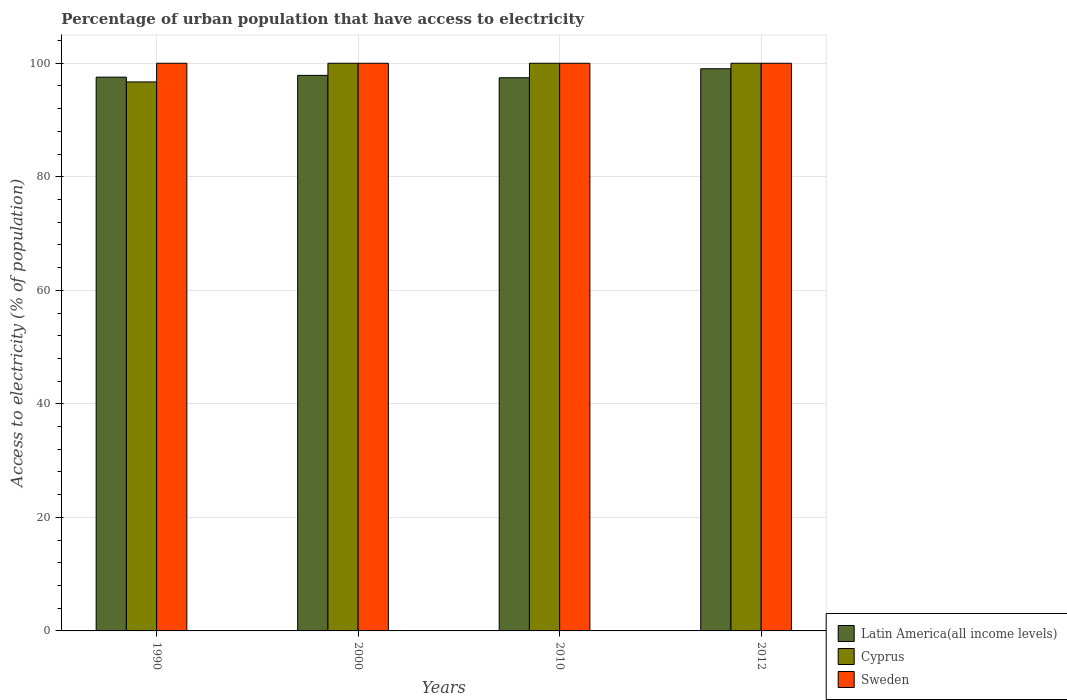How many groups of bars are there?
Your answer should be compact. 4. How many bars are there on the 1st tick from the left?
Your response must be concise. 3. What is the percentage of urban population that have access to electricity in Sweden in 2000?
Offer a terse response. 100. Across all years, what is the maximum percentage of urban population that have access to electricity in Latin America(all income levels)?
Give a very brief answer. 99.03. Across all years, what is the minimum percentage of urban population that have access to electricity in Latin America(all income levels)?
Your response must be concise. 97.45. In which year was the percentage of urban population that have access to electricity in Latin America(all income levels) maximum?
Your answer should be compact. 2012. In which year was the percentage of urban population that have access to electricity in Latin America(all income levels) minimum?
Your response must be concise. 2010. What is the total percentage of urban population that have access to electricity in Latin America(all income levels) in the graph?
Keep it short and to the point. 391.89. What is the difference between the percentage of urban population that have access to electricity in Cyprus in 1990 and that in 2010?
Your response must be concise. -3.29. What is the difference between the percentage of urban population that have access to electricity in Latin America(all income levels) in 2000 and the percentage of urban population that have access to electricity in Sweden in 2010?
Provide a short and direct response. -2.14. What is the average percentage of urban population that have access to electricity in Sweden per year?
Ensure brevity in your answer.  100. In the year 2012, what is the difference between the percentage of urban population that have access to electricity in Latin America(all income levels) and percentage of urban population that have access to electricity in Sweden?
Your answer should be very brief. -0.97. In how many years, is the percentage of urban population that have access to electricity in Sweden greater than 40 %?
Provide a short and direct response. 4. What is the ratio of the percentage of urban population that have access to electricity in Latin America(all income levels) in 1990 to that in 2012?
Your answer should be very brief. 0.99. Is the percentage of urban population that have access to electricity in Latin America(all income levels) in 2000 less than that in 2012?
Provide a succinct answer. Yes. What is the difference between the highest and the second highest percentage of urban population that have access to electricity in Cyprus?
Provide a succinct answer. 0. What is the difference between the highest and the lowest percentage of urban population that have access to electricity in Latin America(all income levels)?
Ensure brevity in your answer.  1.59. In how many years, is the percentage of urban population that have access to electricity in Cyprus greater than the average percentage of urban population that have access to electricity in Cyprus taken over all years?
Make the answer very short. 3. Is the sum of the percentage of urban population that have access to electricity in Cyprus in 1990 and 2000 greater than the maximum percentage of urban population that have access to electricity in Latin America(all income levels) across all years?
Offer a terse response. Yes. What does the 2nd bar from the left in 2012 represents?
Your response must be concise. Cyprus. How many bars are there?
Make the answer very short. 12. Are all the bars in the graph horizontal?
Ensure brevity in your answer.  No. How many years are there in the graph?
Offer a very short reply. 4. What is the difference between two consecutive major ticks on the Y-axis?
Give a very brief answer. 20. Are the values on the major ticks of Y-axis written in scientific E-notation?
Give a very brief answer. No. Where does the legend appear in the graph?
Your response must be concise. Bottom right. How are the legend labels stacked?
Ensure brevity in your answer.  Vertical. What is the title of the graph?
Your response must be concise. Percentage of urban population that have access to electricity. Does "Venezuela" appear as one of the legend labels in the graph?
Your answer should be compact. No. What is the label or title of the X-axis?
Give a very brief answer. Years. What is the label or title of the Y-axis?
Provide a short and direct response. Access to electricity (% of population). What is the Access to electricity (% of population) in Latin America(all income levels) in 1990?
Provide a short and direct response. 97.55. What is the Access to electricity (% of population) of Cyprus in 1990?
Your answer should be compact. 96.71. What is the Access to electricity (% of population) of Sweden in 1990?
Give a very brief answer. 100. What is the Access to electricity (% of population) in Latin America(all income levels) in 2000?
Your answer should be very brief. 97.86. What is the Access to electricity (% of population) in Cyprus in 2000?
Give a very brief answer. 100. What is the Access to electricity (% of population) of Latin America(all income levels) in 2010?
Give a very brief answer. 97.45. What is the Access to electricity (% of population) of Sweden in 2010?
Provide a succinct answer. 100. What is the Access to electricity (% of population) of Latin America(all income levels) in 2012?
Make the answer very short. 99.03. What is the Access to electricity (% of population) of Cyprus in 2012?
Your answer should be compact. 100. Across all years, what is the maximum Access to electricity (% of population) of Latin America(all income levels)?
Provide a succinct answer. 99.03. Across all years, what is the maximum Access to electricity (% of population) of Cyprus?
Give a very brief answer. 100. Across all years, what is the minimum Access to electricity (% of population) in Latin America(all income levels)?
Your response must be concise. 97.45. Across all years, what is the minimum Access to electricity (% of population) of Cyprus?
Provide a succinct answer. 96.71. What is the total Access to electricity (% of population) of Latin America(all income levels) in the graph?
Your answer should be compact. 391.89. What is the total Access to electricity (% of population) in Cyprus in the graph?
Keep it short and to the point. 396.71. What is the difference between the Access to electricity (% of population) in Latin America(all income levels) in 1990 and that in 2000?
Keep it short and to the point. -0.32. What is the difference between the Access to electricity (% of population) in Cyprus in 1990 and that in 2000?
Give a very brief answer. -3.29. What is the difference between the Access to electricity (% of population) of Sweden in 1990 and that in 2000?
Provide a short and direct response. 0. What is the difference between the Access to electricity (% of population) of Latin America(all income levels) in 1990 and that in 2010?
Your answer should be compact. 0.1. What is the difference between the Access to electricity (% of population) of Cyprus in 1990 and that in 2010?
Your response must be concise. -3.29. What is the difference between the Access to electricity (% of population) in Latin America(all income levels) in 1990 and that in 2012?
Provide a short and direct response. -1.48. What is the difference between the Access to electricity (% of population) of Cyprus in 1990 and that in 2012?
Ensure brevity in your answer.  -3.29. What is the difference between the Access to electricity (% of population) of Sweden in 1990 and that in 2012?
Your answer should be very brief. 0. What is the difference between the Access to electricity (% of population) of Latin America(all income levels) in 2000 and that in 2010?
Ensure brevity in your answer.  0.42. What is the difference between the Access to electricity (% of population) of Latin America(all income levels) in 2000 and that in 2012?
Ensure brevity in your answer.  -1.17. What is the difference between the Access to electricity (% of population) of Cyprus in 2000 and that in 2012?
Your answer should be compact. 0. What is the difference between the Access to electricity (% of population) of Latin America(all income levels) in 2010 and that in 2012?
Your answer should be very brief. -1.59. What is the difference between the Access to electricity (% of population) in Sweden in 2010 and that in 2012?
Offer a terse response. 0. What is the difference between the Access to electricity (% of population) in Latin America(all income levels) in 1990 and the Access to electricity (% of population) in Cyprus in 2000?
Provide a succinct answer. -2.45. What is the difference between the Access to electricity (% of population) in Latin America(all income levels) in 1990 and the Access to electricity (% of population) in Sweden in 2000?
Your answer should be compact. -2.45. What is the difference between the Access to electricity (% of population) in Cyprus in 1990 and the Access to electricity (% of population) in Sweden in 2000?
Give a very brief answer. -3.29. What is the difference between the Access to electricity (% of population) in Latin America(all income levels) in 1990 and the Access to electricity (% of population) in Cyprus in 2010?
Keep it short and to the point. -2.45. What is the difference between the Access to electricity (% of population) of Latin America(all income levels) in 1990 and the Access to electricity (% of population) of Sweden in 2010?
Keep it short and to the point. -2.45. What is the difference between the Access to electricity (% of population) in Cyprus in 1990 and the Access to electricity (% of population) in Sweden in 2010?
Give a very brief answer. -3.29. What is the difference between the Access to electricity (% of population) of Latin America(all income levels) in 1990 and the Access to electricity (% of population) of Cyprus in 2012?
Give a very brief answer. -2.45. What is the difference between the Access to electricity (% of population) in Latin America(all income levels) in 1990 and the Access to electricity (% of population) in Sweden in 2012?
Keep it short and to the point. -2.45. What is the difference between the Access to electricity (% of population) of Cyprus in 1990 and the Access to electricity (% of population) of Sweden in 2012?
Your answer should be compact. -3.29. What is the difference between the Access to electricity (% of population) in Latin America(all income levels) in 2000 and the Access to electricity (% of population) in Cyprus in 2010?
Keep it short and to the point. -2.14. What is the difference between the Access to electricity (% of population) of Latin America(all income levels) in 2000 and the Access to electricity (% of population) of Sweden in 2010?
Provide a succinct answer. -2.14. What is the difference between the Access to electricity (% of population) of Latin America(all income levels) in 2000 and the Access to electricity (% of population) of Cyprus in 2012?
Your answer should be very brief. -2.14. What is the difference between the Access to electricity (% of population) in Latin America(all income levels) in 2000 and the Access to electricity (% of population) in Sweden in 2012?
Provide a succinct answer. -2.14. What is the difference between the Access to electricity (% of population) of Cyprus in 2000 and the Access to electricity (% of population) of Sweden in 2012?
Give a very brief answer. 0. What is the difference between the Access to electricity (% of population) of Latin America(all income levels) in 2010 and the Access to electricity (% of population) of Cyprus in 2012?
Your answer should be very brief. -2.55. What is the difference between the Access to electricity (% of population) of Latin America(all income levels) in 2010 and the Access to electricity (% of population) of Sweden in 2012?
Keep it short and to the point. -2.55. What is the difference between the Access to electricity (% of population) in Cyprus in 2010 and the Access to electricity (% of population) in Sweden in 2012?
Your response must be concise. 0. What is the average Access to electricity (% of population) of Latin America(all income levels) per year?
Make the answer very short. 97.97. What is the average Access to electricity (% of population) of Cyprus per year?
Provide a succinct answer. 99.18. In the year 1990, what is the difference between the Access to electricity (% of population) of Latin America(all income levels) and Access to electricity (% of population) of Cyprus?
Give a very brief answer. 0.84. In the year 1990, what is the difference between the Access to electricity (% of population) in Latin America(all income levels) and Access to electricity (% of population) in Sweden?
Provide a short and direct response. -2.45. In the year 1990, what is the difference between the Access to electricity (% of population) of Cyprus and Access to electricity (% of population) of Sweden?
Offer a very short reply. -3.29. In the year 2000, what is the difference between the Access to electricity (% of population) in Latin America(all income levels) and Access to electricity (% of population) in Cyprus?
Make the answer very short. -2.14. In the year 2000, what is the difference between the Access to electricity (% of population) in Latin America(all income levels) and Access to electricity (% of population) in Sweden?
Your answer should be compact. -2.14. In the year 2000, what is the difference between the Access to electricity (% of population) of Cyprus and Access to electricity (% of population) of Sweden?
Your response must be concise. 0. In the year 2010, what is the difference between the Access to electricity (% of population) of Latin America(all income levels) and Access to electricity (% of population) of Cyprus?
Your response must be concise. -2.55. In the year 2010, what is the difference between the Access to electricity (% of population) of Latin America(all income levels) and Access to electricity (% of population) of Sweden?
Your response must be concise. -2.55. In the year 2012, what is the difference between the Access to electricity (% of population) of Latin America(all income levels) and Access to electricity (% of population) of Cyprus?
Offer a terse response. -0.97. In the year 2012, what is the difference between the Access to electricity (% of population) of Latin America(all income levels) and Access to electricity (% of population) of Sweden?
Offer a very short reply. -0.97. In the year 2012, what is the difference between the Access to electricity (% of population) of Cyprus and Access to electricity (% of population) of Sweden?
Give a very brief answer. 0. What is the ratio of the Access to electricity (% of population) in Latin America(all income levels) in 1990 to that in 2000?
Keep it short and to the point. 1. What is the ratio of the Access to electricity (% of population) in Cyprus in 1990 to that in 2000?
Your answer should be very brief. 0.97. What is the ratio of the Access to electricity (% of population) of Cyprus in 1990 to that in 2010?
Ensure brevity in your answer.  0.97. What is the ratio of the Access to electricity (% of population) of Latin America(all income levels) in 1990 to that in 2012?
Offer a terse response. 0.98. What is the ratio of the Access to electricity (% of population) of Cyprus in 1990 to that in 2012?
Your response must be concise. 0.97. What is the ratio of the Access to electricity (% of population) of Sweden in 1990 to that in 2012?
Give a very brief answer. 1. What is the ratio of the Access to electricity (% of population) in Latin America(all income levels) in 2000 to that in 2010?
Offer a terse response. 1. What is the ratio of the Access to electricity (% of population) in Cyprus in 2000 to that in 2010?
Make the answer very short. 1. What is the ratio of the Access to electricity (% of population) of Latin America(all income levels) in 2000 to that in 2012?
Give a very brief answer. 0.99. What is the ratio of the Access to electricity (% of population) in Cyprus in 2000 to that in 2012?
Your answer should be very brief. 1. What is the ratio of the Access to electricity (% of population) of Latin America(all income levels) in 2010 to that in 2012?
Your response must be concise. 0.98. What is the ratio of the Access to electricity (% of population) of Cyprus in 2010 to that in 2012?
Offer a terse response. 1. What is the ratio of the Access to electricity (% of population) of Sweden in 2010 to that in 2012?
Keep it short and to the point. 1. What is the difference between the highest and the second highest Access to electricity (% of population) in Latin America(all income levels)?
Provide a short and direct response. 1.17. What is the difference between the highest and the second highest Access to electricity (% of population) of Cyprus?
Offer a very short reply. 0. What is the difference between the highest and the lowest Access to electricity (% of population) of Latin America(all income levels)?
Your answer should be very brief. 1.59. What is the difference between the highest and the lowest Access to electricity (% of population) in Cyprus?
Ensure brevity in your answer.  3.29. What is the difference between the highest and the lowest Access to electricity (% of population) of Sweden?
Your answer should be very brief. 0. 